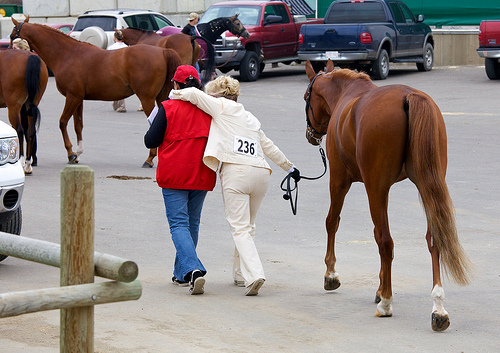<image>
Is the horse on the woman? No. The horse is not positioned on the woman. They may be near each other, but the horse is not supported by or resting on top of the woman. Where is the horse in relation to the truck? Is it under the truck? No. The horse is not positioned under the truck. The vertical relationship between these objects is different. 